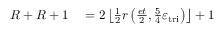Convert formula to latex. <formula><loc_0><loc_0><loc_500><loc_500>\begin{array} { r l } { R + R + 1 } & = 2 \left \lfloor \frac { 1 } { 2 } r \left ( \frac { e t } { 2 } , \frac { 5 } { 4 } \varepsilon _ { t r i } \right ) \right \rfloor + 1 } \end{array}</formula> 